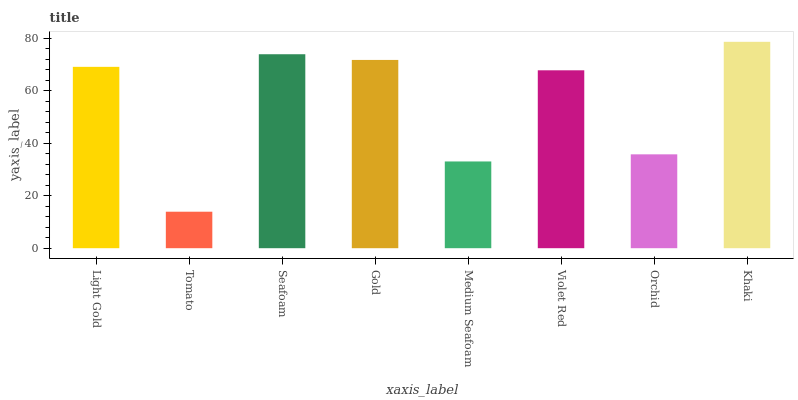Is Tomato the minimum?
Answer yes or no. Yes. Is Khaki the maximum?
Answer yes or no. Yes. Is Seafoam the minimum?
Answer yes or no. No. Is Seafoam the maximum?
Answer yes or no. No. Is Seafoam greater than Tomato?
Answer yes or no. Yes. Is Tomato less than Seafoam?
Answer yes or no. Yes. Is Tomato greater than Seafoam?
Answer yes or no. No. Is Seafoam less than Tomato?
Answer yes or no. No. Is Light Gold the high median?
Answer yes or no. Yes. Is Violet Red the low median?
Answer yes or no. Yes. Is Khaki the high median?
Answer yes or no. No. Is Tomato the low median?
Answer yes or no. No. 